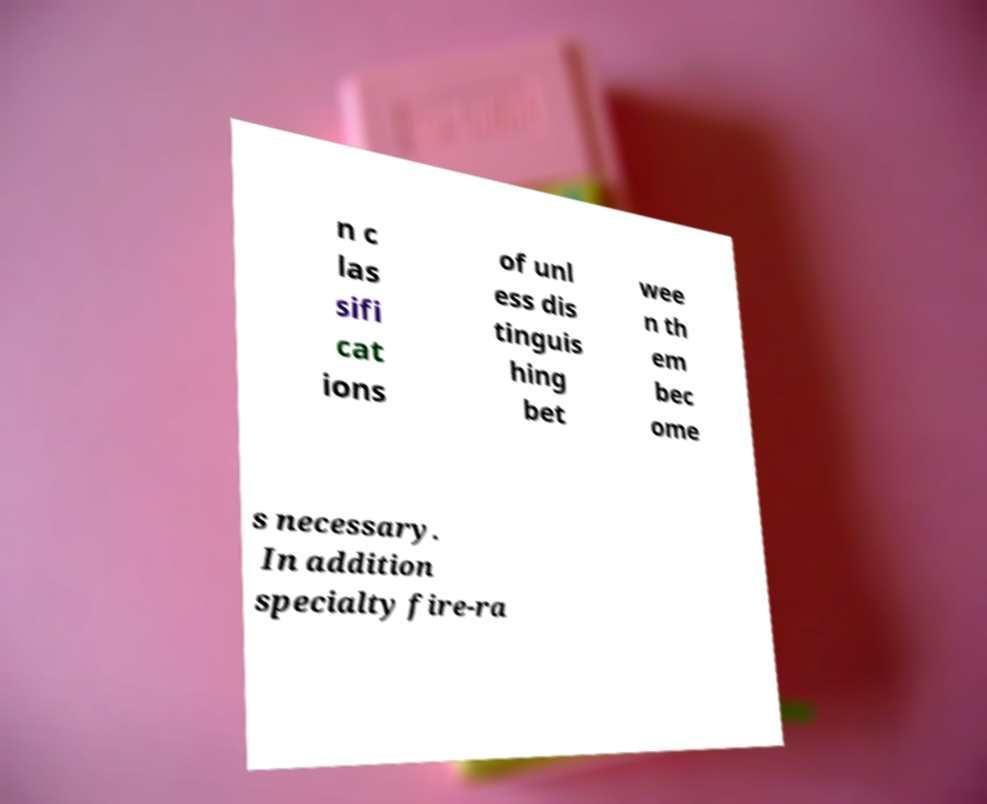There's text embedded in this image that I need extracted. Can you transcribe it verbatim? n c las sifi cat ions of unl ess dis tinguis hing bet wee n th em bec ome s necessary. In addition specialty fire-ra 